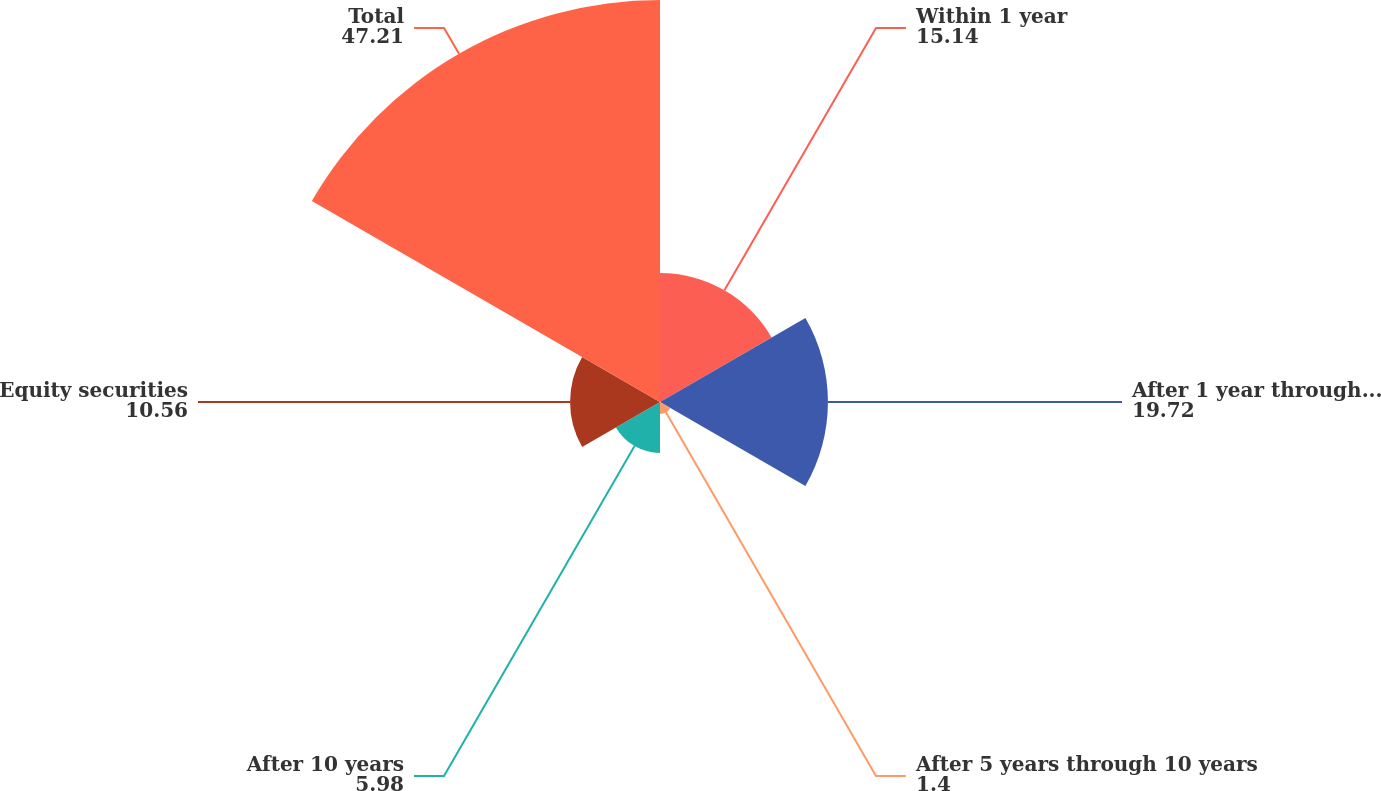Convert chart. <chart><loc_0><loc_0><loc_500><loc_500><pie_chart><fcel>Within 1 year<fcel>After 1 year through 5 years<fcel>After 5 years through 10 years<fcel>After 10 years<fcel>Equity securities<fcel>Total<nl><fcel>15.14%<fcel>19.72%<fcel>1.4%<fcel>5.98%<fcel>10.56%<fcel>47.21%<nl></chart> 